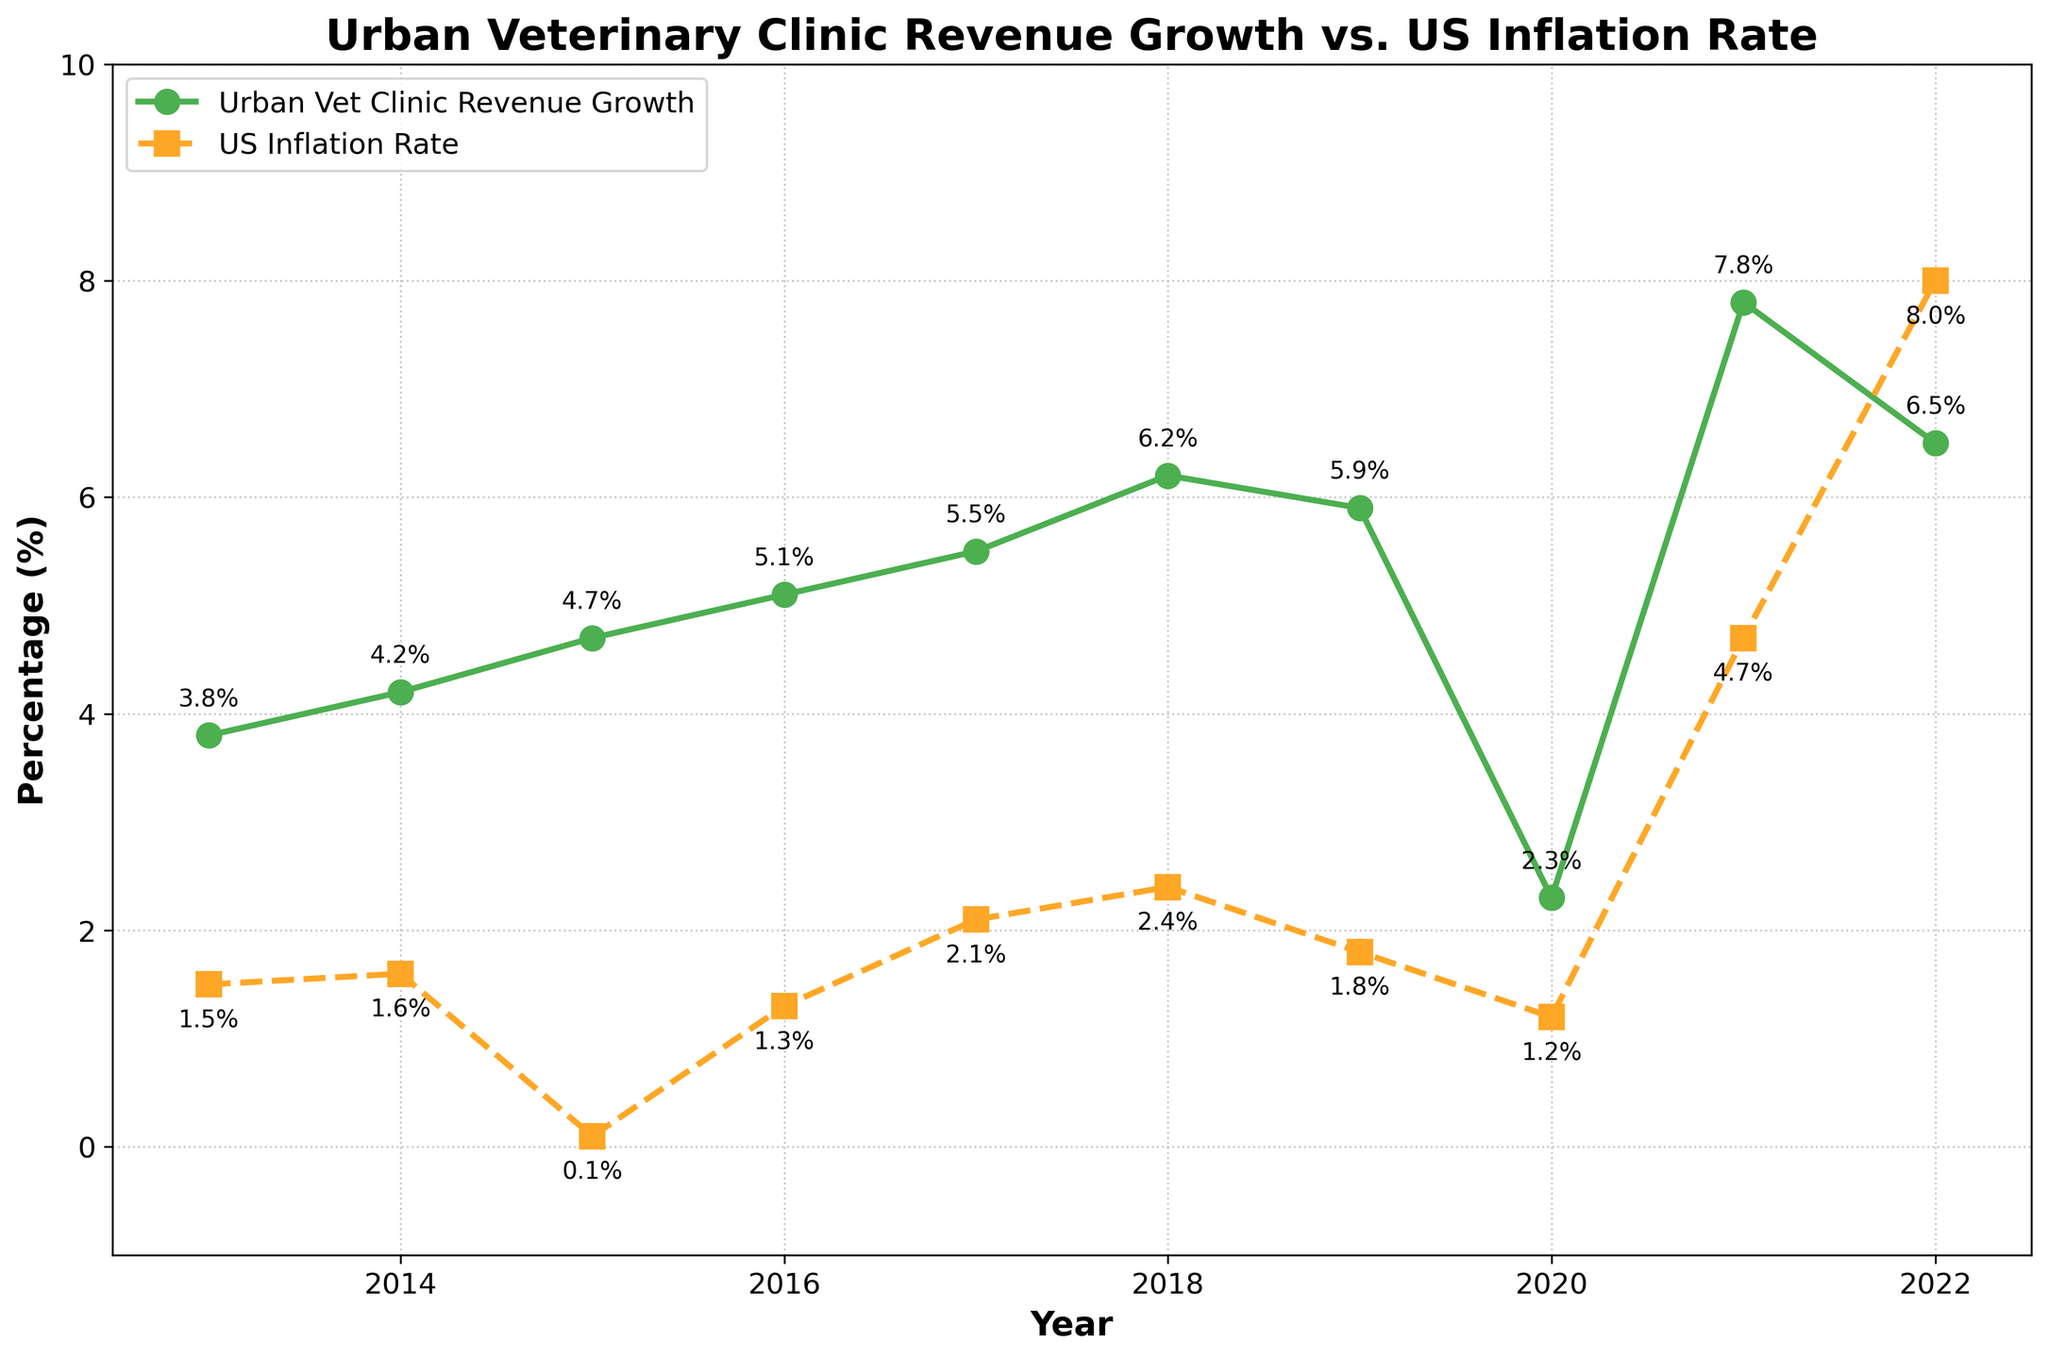Which year has the highest revenue growth for urban veterinary clinics? The highest point on the revenue growth line (green line) corresponds to the year.
Answer: 2021 In which year does the revenue growth of urban veterinary clinics most significantly surpass the inflation rate? Compare the gaps between the green and orange lines each year. The largest gap indicates the answer.
Answer: 2021 What is the average revenue growth of urban veterinary clinics from 2013 to 2022? Sum all revenue growth values and divide by the number of years (10).
Answer: 5.2% How does the revenue growth in 2020 compare to the inflation rate that year? Look at the points for 2020 on both lines and compare their values.
Answer: Higher Is there any year when the inflation rate is greater than the revenue growth of urban veterinary clinics? Check each year to see if the orange line (inflation) goes above the green line (revenue growth) value.
Answer: Yes, 2022 What is the general trend of urban veterinary clinic revenue growth from 2013 to 2021? Observe the direction of the green line from 2013 to 2021 to determine if it is generally increasing or decreasing.
Answer: Generally increasing How does the inflation rate change from 2015 to 2022? Observe the pattern of the orange line from 2015 to 2022 to determine if it is generally increasing or decreasing.
Answer: Generally increasing By how much did the revenue growth increase from 2014 to 2017? Subtract the revenue growth value of 2014 from the value of 2017.
Answer: 1.3% In which year is the difference between revenue growth and inflation rate the smallest? Find the year where the gap between the green line and the orange line is the smallest.
Answer: 2022 Which year has the highest inflation rate shown in the chart? The highest point on the inflation rate line (orange line) gives the year.
Answer: 2022 